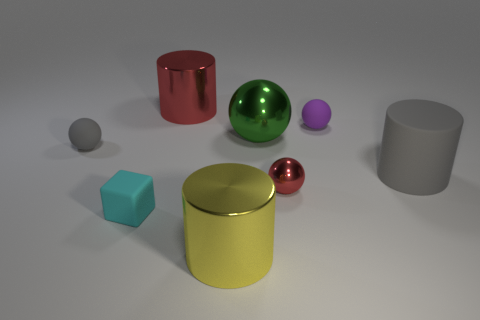Subtract 1 spheres. How many spheres are left? 3 Add 2 small cyan cubes. How many objects exist? 10 Subtract all cylinders. How many objects are left? 5 Add 7 green shiny things. How many green shiny things are left? 8 Add 2 small purple things. How many small purple things exist? 3 Subtract 1 yellow cylinders. How many objects are left? 7 Subtract all small brown shiny balls. Subtract all red metallic things. How many objects are left? 6 